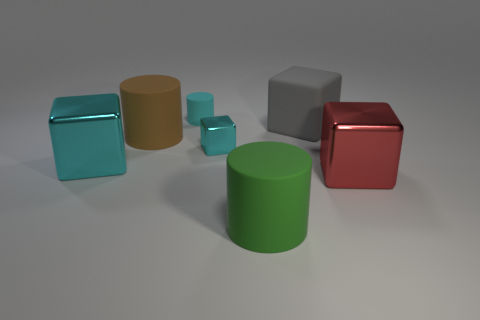Add 1 gray shiny balls. How many objects exist? 8 Subtract all small cubes. How many cubes are left? 3 Subtract all gray blocks. How many blocks are left? 3 Subtract all blocks. How many objects are left? 3 Subtract all gray blocks. Subtract all brown cylinders. How many blocks are left? 3 Subtract all gray cylinders. How many purple blocks are left? 0 Subtract all large things. Subtract all tiny green balls. How many objects are left? 2 Add 3 green matte things. How many green matte things are left? 4 Add 5 big green rubber objects. How many big green rubber objects exist? 6 Subtract 0 purple cylinders. How many objects are left? 7 